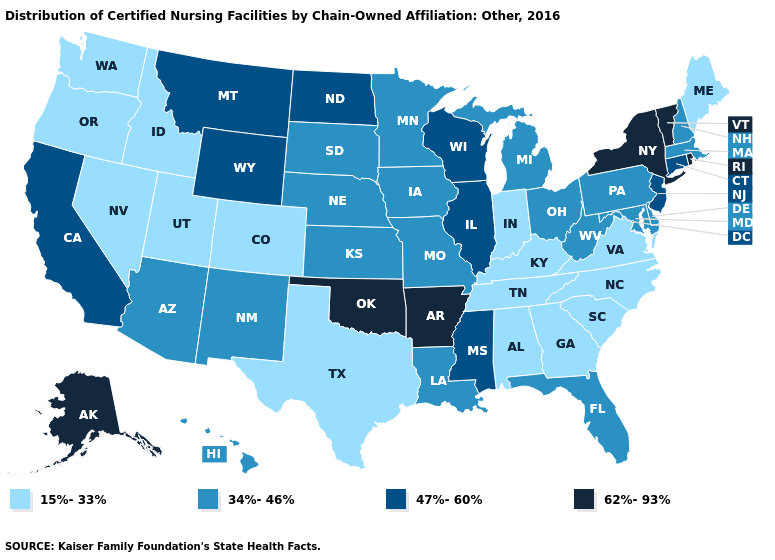What is the value of West Virginia?
Answer briefly. 34%-46%. What is the value of Virginia?
Concise answer only. 15%-33%. Name the states that have a value in the range 34%-46%?
Concise answer only. Arizona, Delaware, Florida, Hawaii, Iowa, Kansas, Louisiana, Maryland, Massachusetts, Michigan, Minnesota, Missouri, Nebraska, New Hampshire, New Mexico, Ohio, Pennsylvania, South Dakota, West Virginia. What is the value of Alabama?
Write a very short answer. 15%-33%. Does Nevada have the same value as Iowa?
Short answer required. No. What is the highest value in the USA?
Answer briefly. 62%-93%. Name the states that have a value in the range 15%-33%?
Answer briefly. Alabama, Colorado, Georgia, Idaho, Indiana, Kentucky, Maine, Nevada, North Carolina, Oregon, South Carolina, Tennessee, Texas, Utah, Virginia, Washington. Does New Mexico have the highest value in the USA?
Answer briefly. No. What is the value of Iowa?
Give a very brief answer. 34%-46%. What is the value of Florida?
Answer briefly. 34%-46%. Does Minnesota have a higher value than New Hampshire?
Quick response, please. No. Does Delaware have the same value as Wisconsin?
Give a very brief answer. No. Among the states that border New Mexico , which have the highest value?
Short answer required. Oklahoma. Name the states that have a value in the range 62%-93%?
Quick response, please. Alaska, Arkansas, New York, Oklahoma, Rhode Island, Vermont. 